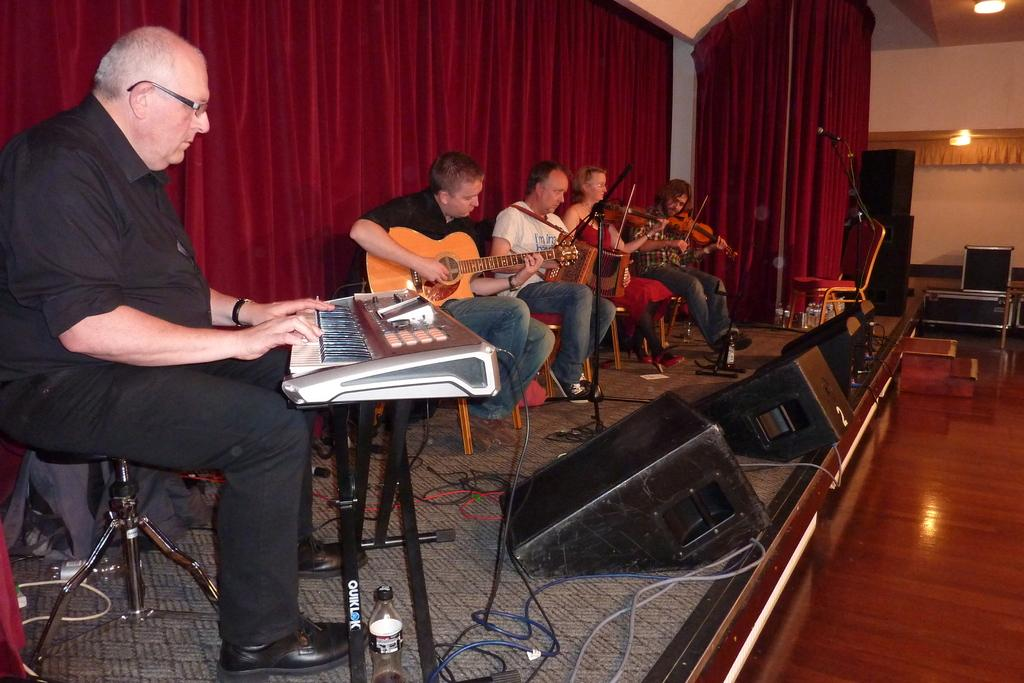How many people are in the image? There are 5 persons in the image. What are the persons in the image doing? The persons are sitting. What are the persons holding in the image? Each person is holding a musical instrument. What can be seen in the background of the image? There is a curtain, a wall, and lights visible in the background of the image. What type of yarn is being used by the person holding a guitar in the image? There is no yarn present in the image, and no person is holding a guitar. How much oil is visible on the floor in the image? There is no oil visible on the floor in the image. 